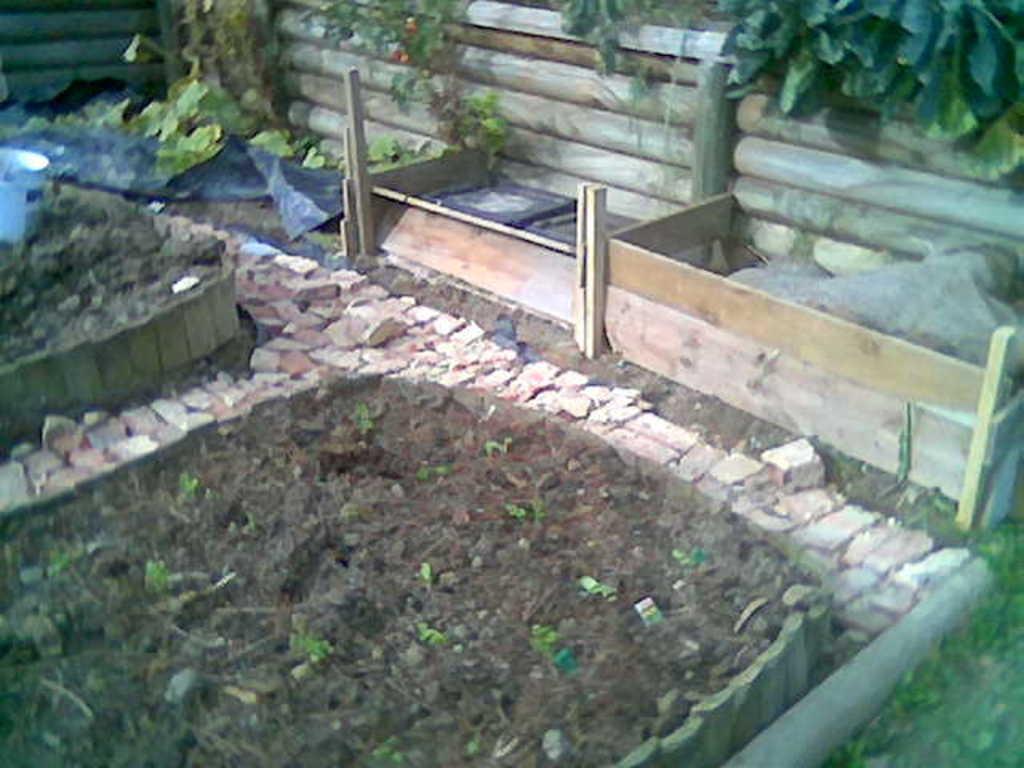How would you summarize this image in a sentence or two? In the foreground of this image, there are few small plants in the soil, few stones, two wooden objects, a black plastic sheet and few plants at the top and we can also see the wooden railing. 